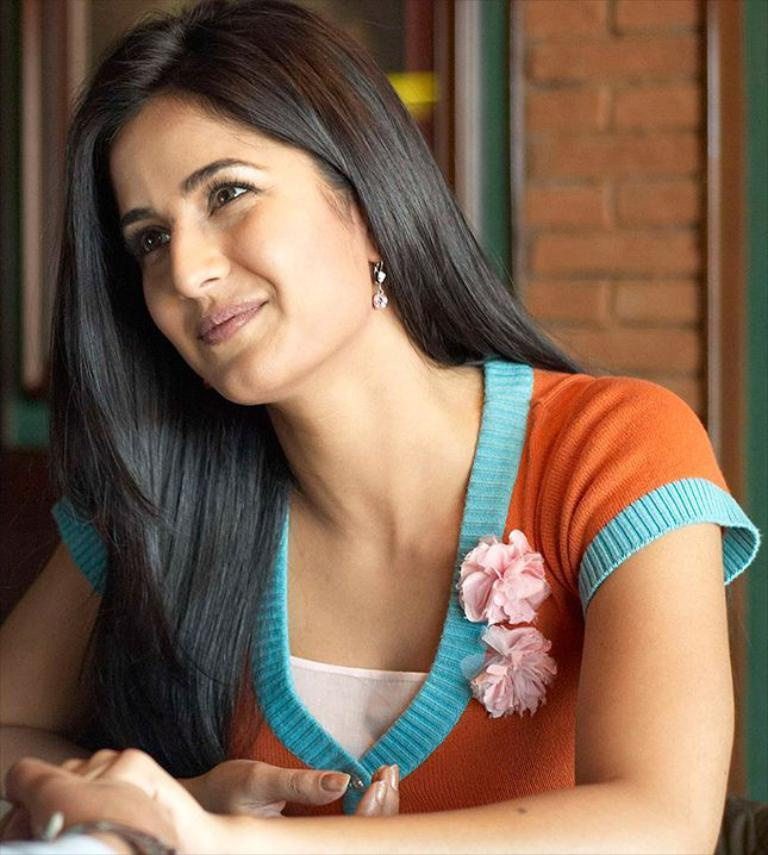What is the woman in the image doing? The woman is sitting in the image and smiling. Can you describe the hand visible in the bottom of the image? There is another hand visible in the bottom of the image, but its owner or action cannot be determined from the image. What is visible in the background of the image? There is a wall and a window in the background of the image. What type of window treatment is present in the image? There is a curtain associated with the window in the image. What type of cracker is being used to frame the woman in the image? There is no cracker present in the image, and it is not being used to frame the woman. 